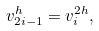Convert formula to latex. <formula><loc_0><loc_0><loc_500><loc_500>v ^ { h } _ { 2 i - 1 } = v ^ { 2 h } _ { i } ,</formula> 